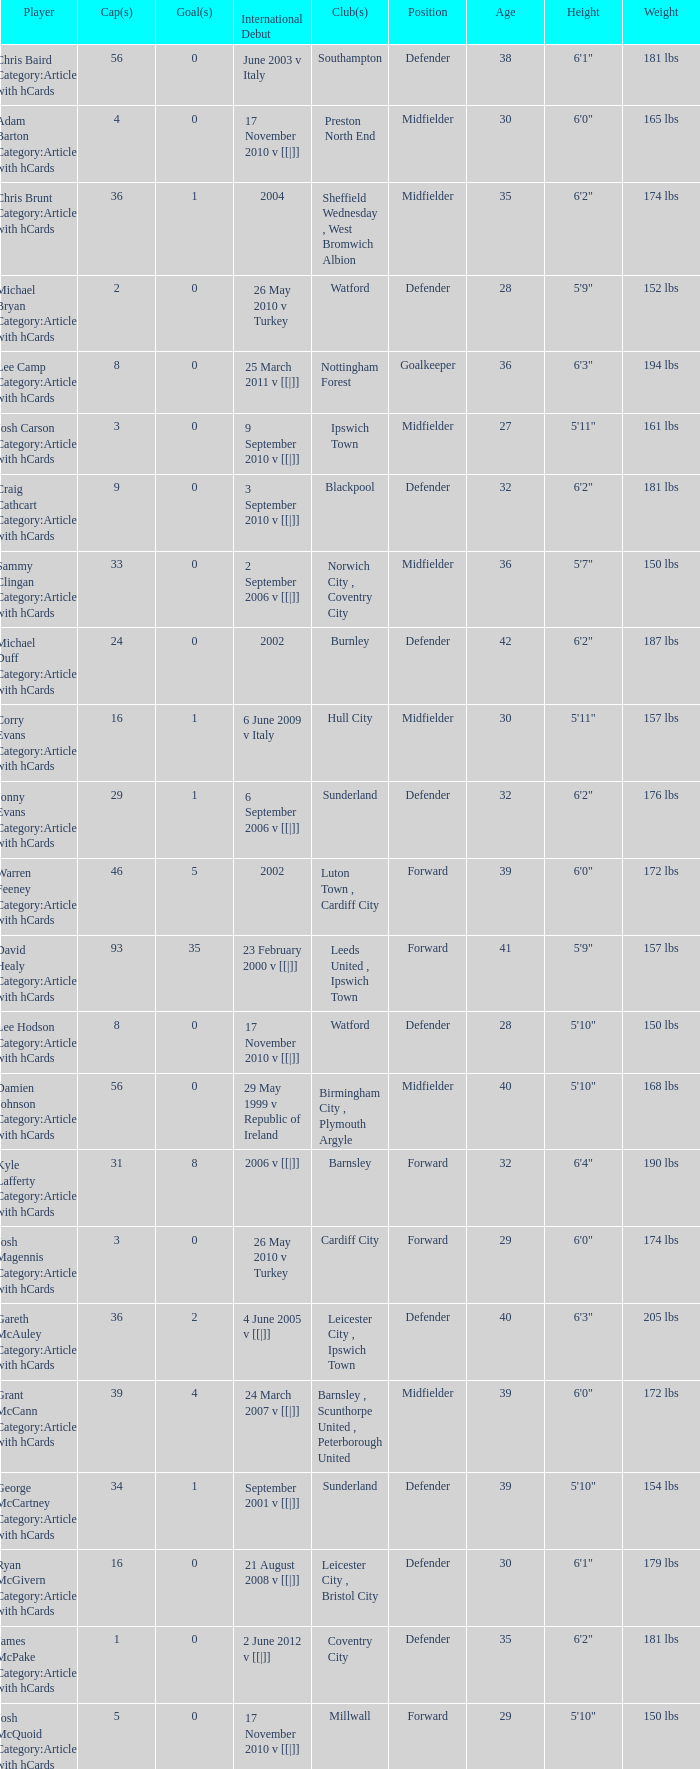How many caps figures for the Doncaster Rovers? 1.0. 